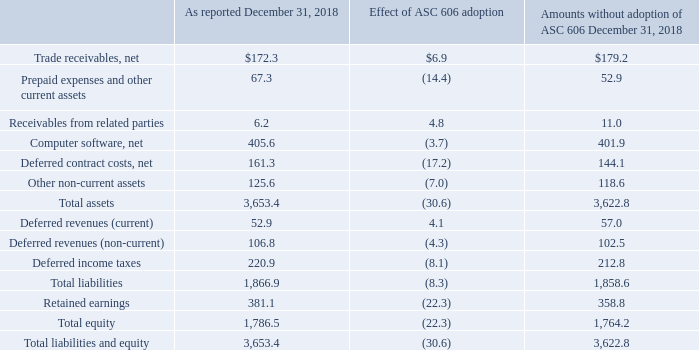Effect of ASC 606 as of December 31, 2018 and for the Year Ended December 31, 2018
The following table summarizes the effect of adopting ASC 606 on our Consolidated Balance Sheet (in millions):
What were the Receivables from related parties as reported in 2018?
Answer scale should be: million. 6.2. What was the effect of ASC 606 adoption on net computer software?
Answer scale should be: million. (3.7). What were the total assets without the adoption of ASC 606?
Answer scale should be: million. 3,622.8. What was the difference the effect of ASC 606 Adoption between Total Assets and Total Liabilities?
Answer scale should be: million. -8.3-(-30.6)
Answer: 22.3. What was total equity as a percentage of total liabilities and equity as reported in 2018?
Answer scale should be: percent. 1,786.5/3,653.4
Answer: 48.9. What was the difference in the reported amount in 2018 between net computer software and net deferred contract costs?
Answer scale should be: million. 405.6-161.3
Answer: 244.3. 